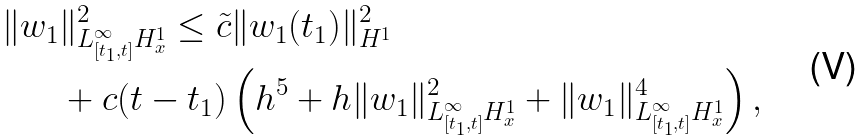Convert formula to latex. <formula><loc_0><loc_0><loc_500><loc_500>\| w _ { 1 } & \| ^ { 2 } _ { L ^ { \infty } _ { [ t _ { 1 } , t ] } H ^ { 1 } _ { x } } \leq \tilde { c } \| w _ { 1 } ( t _ { 1 } ) \| ^ { 2 } _ { H ^ { 1 } } \\ & + c ( t - t _ { 1 } ) \left ( h ^ { 5 } + h \| w _ { 1 } \| _ { L ^ { \infty } _ { [ t _ { 1 } , t ] } H ^ { 1 } _ { x } } ^ { 2 } + \| w _ { 1 } \| _ { L ^ { \infty } _ { [ t _ { 1 } , t ] } H ^ { 1 } _ { x } } ^ { 4 } \right ) ,</formula> 